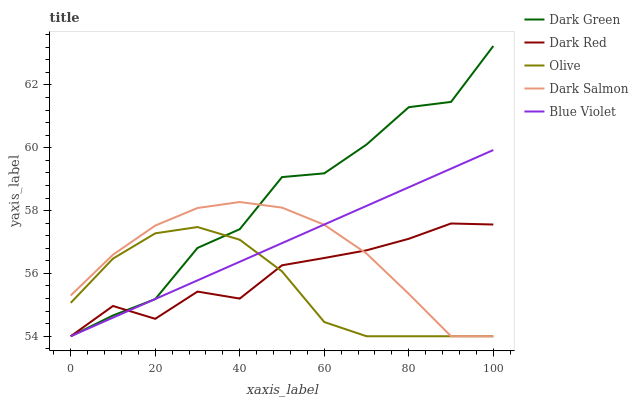Does Olive have the minimum area under the curve?
Answer yes or no. Yes. Does Dark Green have the maximum area under the curve?
Answer yes or no. Yes. Does Dark Red have the minimum area under the curve?
Answer yes or no. No. Does Dark Red have the maximum area under the curve?
Answer yes or no. No. Is Blue Violet the smoothest?
Answer yes or no. Yes. Is Dark Green the roughest?
Answer yes or no. Yes. Is Dark Red the smoothest?
Answer yes or no. No. Is Dark Red the roughest?
Answer yes or no. No. Does Dark Green have the highest value?
Answer yes or no. Yes. Does Dark Red have the highest value?
Answer yes or no. No. Does Dark Green intersect Olive?
Answer yes or no. Yes. Is Dark Green less than Olive?
Answer yes or no. No. Is Dark Green greater than Olive?
Answer yes or no. No. 